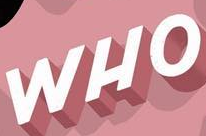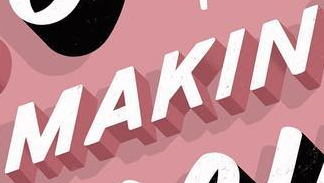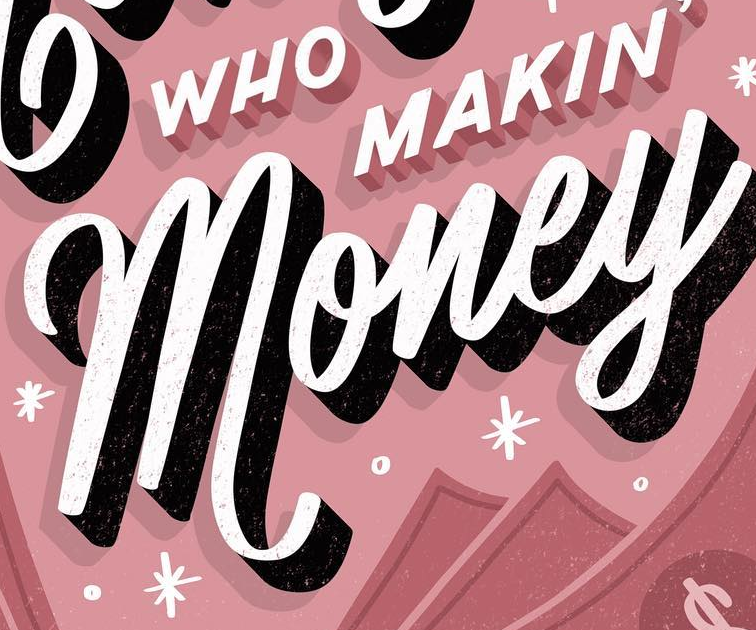What text is displayed in these images sequentially, separated by a semicolon? WHO; MAKIN; money 